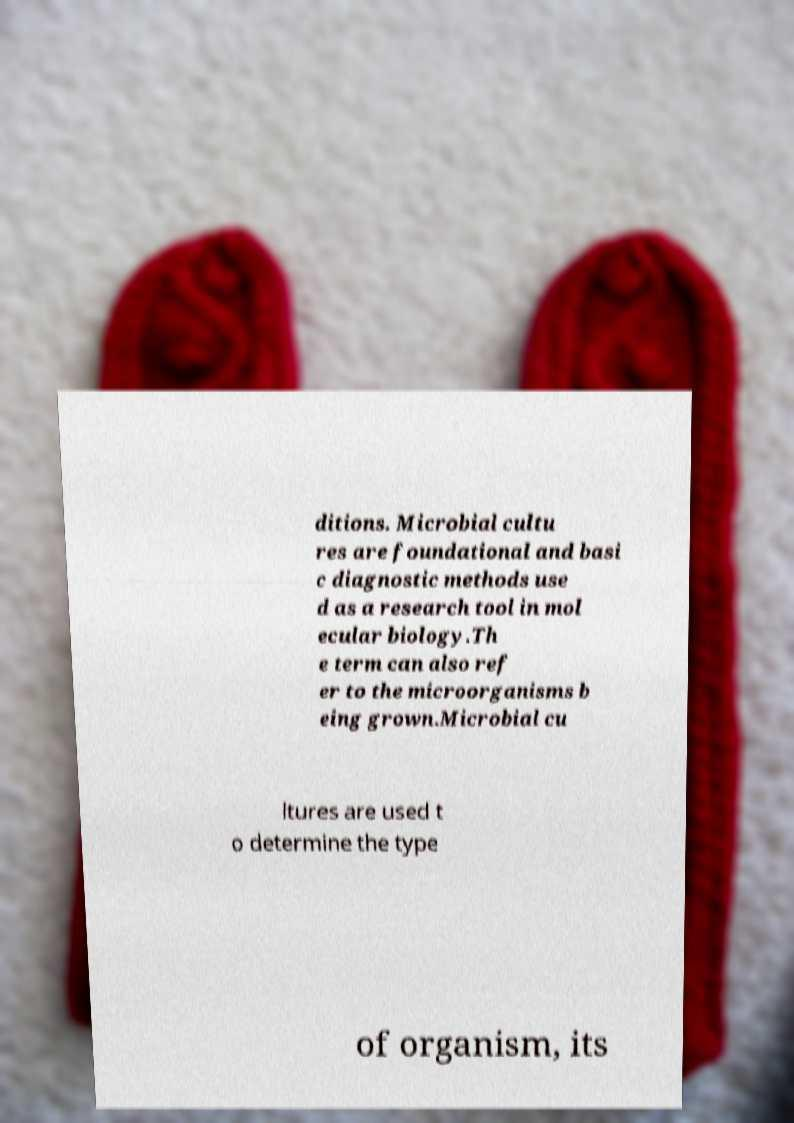What messages or text are displayed in this image? I need them in a readable, typed format. ditions. Microbial cultu res are foundational and basi c diagnostic methods use d as a research tool in mol ecular biology.Th e term can also ref er to the microorganisms b eing grown.Microbial cu ltures are used t o determine the type of organism, its 